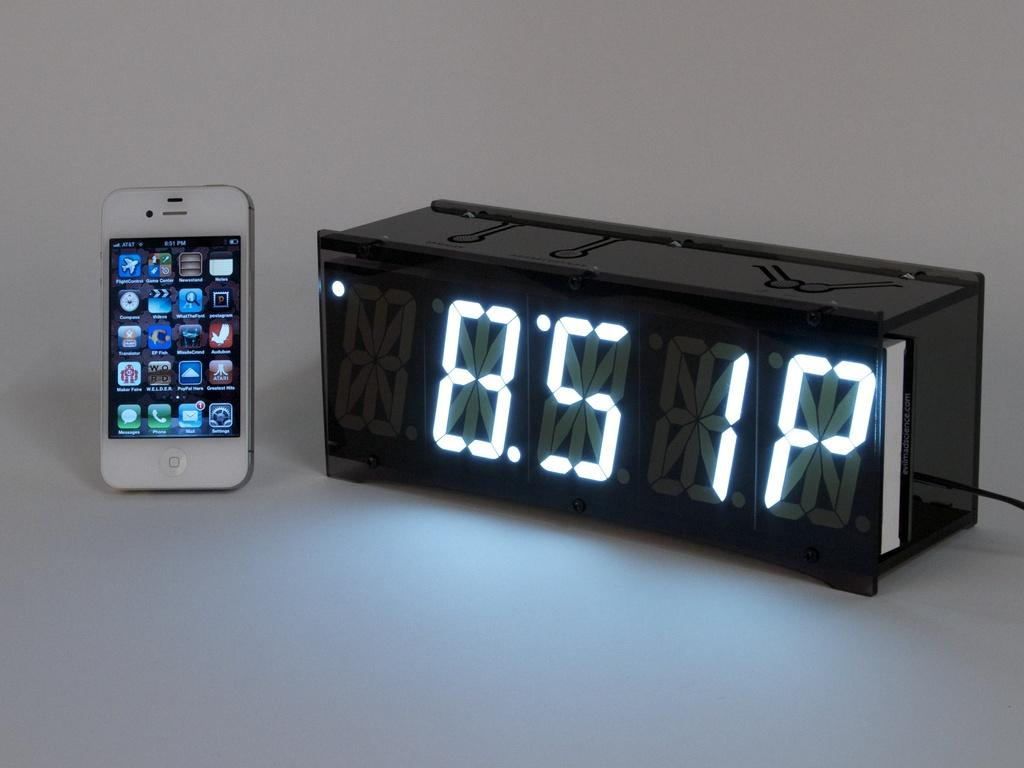<image>
Relay a brief, clear account of the picture shown. A digital clock displaying the time as 8:51PM in white LED. 